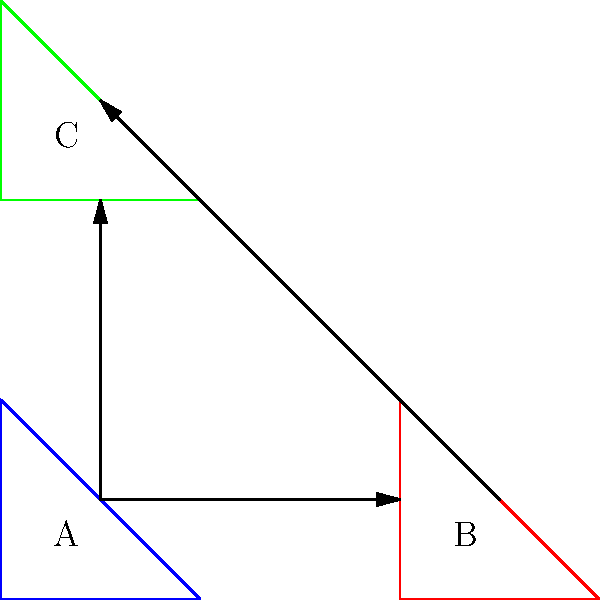As a package store owner in Connecticut, you're considering implementing a new loyalty program. You've been presented with three different loyalty program structures (A, B, and C) as shown in the diagram. Each structure represents a different way of organizing customer tiers and benefits. The arrows between the structures represent possible isomorphisms. Which of the following statements is true about the isomorphisms between these loyalty program structures?

a) A is isomorphic to B, but not to C
b) A is isomorphic to C, but not to B
c) A, B, and C are all isomorphic to each other
d) A, B, and C are not isomorphic to each other To determine the isomorphisms between the loyalty program structures, we need to analyze their properties:

1. All three structures (A, B, and C) are triangles, representing three-tier loyalty programs.

2. In group theory, these structures can be represented as cyclic groups of order 3, denoted as $C_3$.

3. For two structures to be isomorphic, they must have the same group properties. In this case, we're looking at:
   - The number of elements (vertices): All have 3
   - The order of the group: All are of order 3
   - The cycle structure: All complete a cycle in 3 steps

4. The arrows in the diagram represent possible isomorphisms:
   - There's an arrow from A to B
   - There's an arrow from A to C
   - There's an arrow from B to C

5. Since all three structures have the same group properties and there are arrows connecting all of them (directly or indirectly), we can conclude that A, B, and C are all isomorphic to each other.

6. In the context of loyalty programs, this means that despite visual differences, all three structures represent equivalent ways of organizing a three-tier loyalty program. You could implement any of these structures and achieve the same fundamental loyalty program structure.

Therefore, the correct answer is that A, B, and C are all isomorphic to each other.
Answer: c) A, B, and C are all isomorphic to each other 